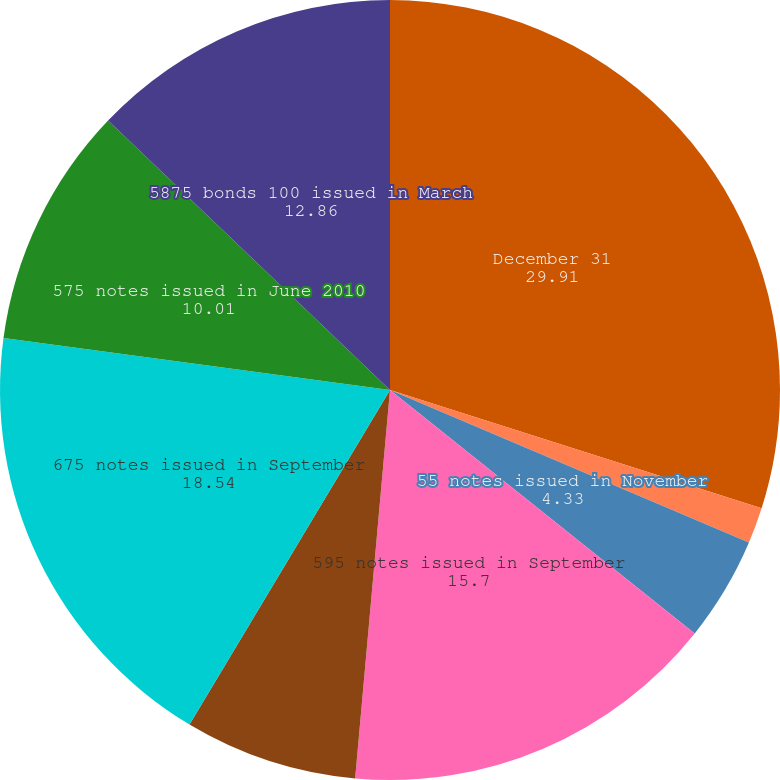<chart> <loc_0><loc_0><loc_500><loc_500><pie_chart><fcel>December 31<fcel>5375 notes issued in March<fcel>55 notes issued in November<fcel>595 notes issued in September<fcel>5375 notes issued in September<fcel>675 notes issued in September<fcel>575 notes issued in June 2010<fcel>5875 bonds 100 issued in March<nl><fcel>29.91%<fcel>1.49%<fcel>4.33%<fcel>15.7%<fcel>7.17%<fcel>18.54%<fcel>10.01%<fcel>12.86%<nl></chart> 